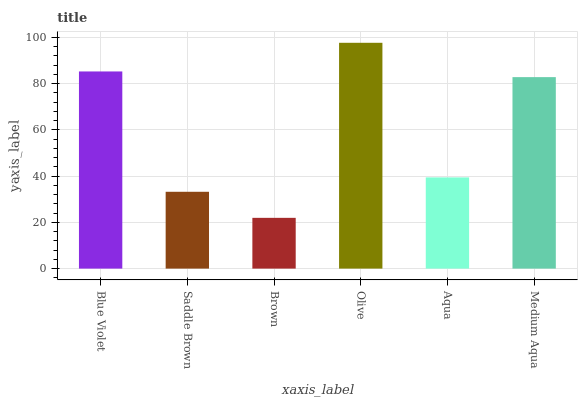Is Saddle Brown the minimum?
Answer yes or no. No. Is Saddle Brown the maximum?
Answer yes or no. No. Is Blue Violet greater than Saddle Brown?
Answer yes or no. Yes. Is Saddle Brown less than Blue Violet?
Answer yes or no. Yes. Is Saddle Brown greater than Blue Violet?
Answer yes or no. No. Is Blue Violet less than Saddle Brown?
Answer yes or no. No. Is Medium Aqua the high median?
Answer yes or no. Yes. Is Aqua the low median?
Answer yes or no. Yes. Is Olive the high median?
Answer yes or no. No. Is Blue Violet the low median?
Answer yes or no. No. 